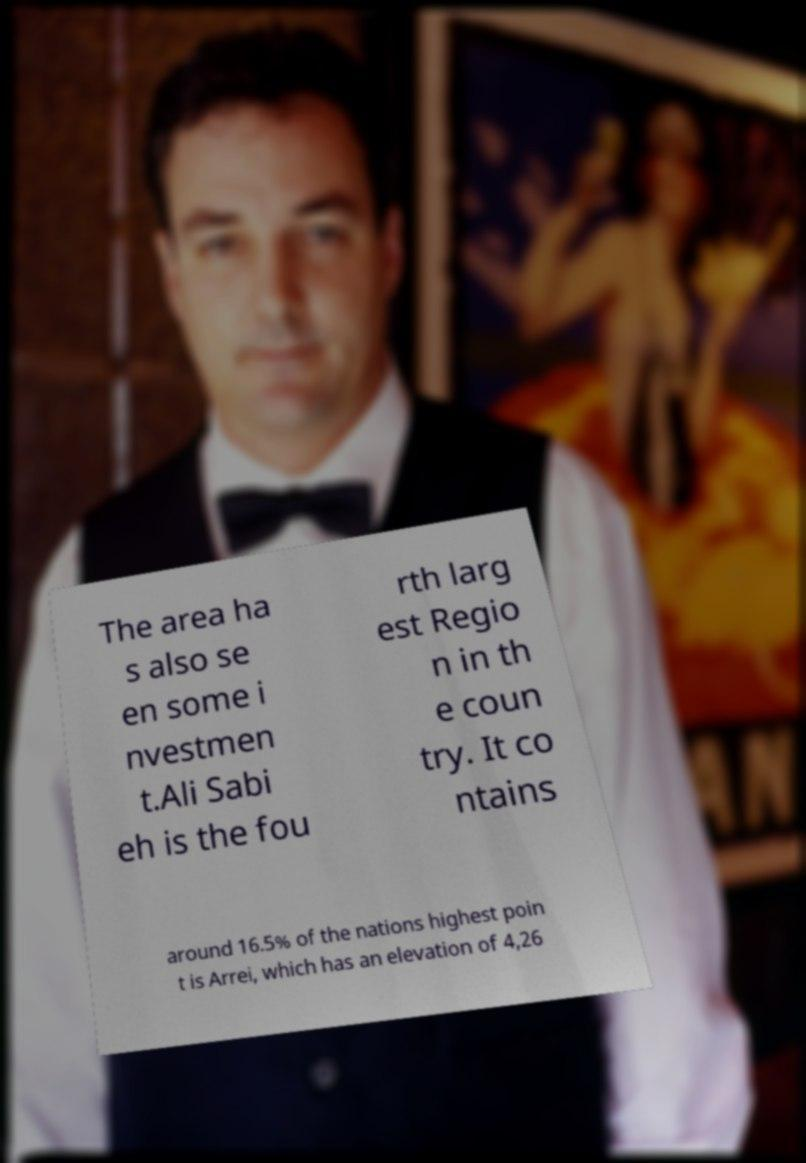I need the written content from this picture converted into text. Can you do that? The area ha s also se en some i nvestmen t.Ali Sabi eh is the fou rth larg est Regio n in th e coun try. It co ntains around 16.5% of the nations highest poin t is Arrei, which has an elevation of 4,26 